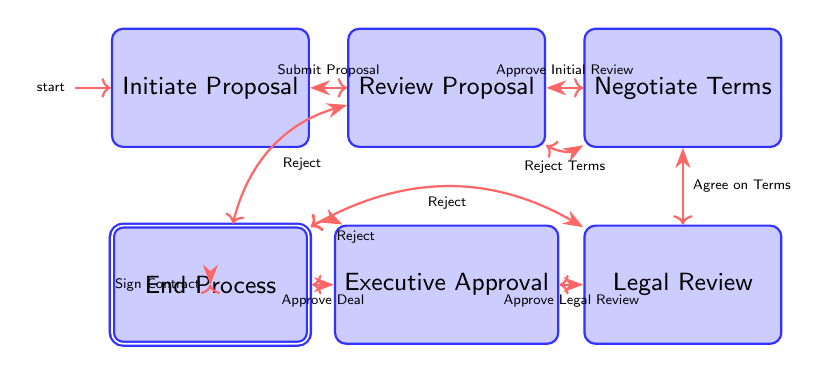What is the first node in the process? The first node in the process is labeled "Initiate Proposal," which indicates the starting point for drafting the football sponsorship proposal.
Answer: Initiate Proposal How many transitions are there from the "Review Proposal" node? The "Review Proposal" node has two transitions: one for approving the initial review and another for rejection. This totals up to two transitions.
Answer: 2 What is the final state of the process? The final state of the process is "End Process," which signifies the conclusion, either with a final deal or a rejected proposal.
Answer: End Process What happens if the proposal is rejected after the initial review? If the proposal is rejected after the initial review, the process transitions to the "End Process" node, indicating that the proposal is not pursued further.
Answer: End Process What is the outcome after "Approve Legal Review"? After "Approve Legal Review," the process transitions to the "Executive Approval" node, where the final approval is sought from top executives before proceeding.
Answer: Executive Approval If terms are rejected during negotiations, where do you go next? If the terms are rejected during negotiations, the process goes back to the "Review Proposal" node to possibly revise the proposal and renegotiate terms.
Answer: Review Proposal How many nodes are there in total in this diagram? There are a total of six nodes in the diagram: Initiate Proposal, Review Proposal, Negotiate Terms, Legal Review, Executive Approval, and Finalize Contract.
Answer: 6 What step follows "Agree on Terms"? The step that follows "Agree on Terms" is "Legal Review," where the terms of the sponsorship deal are examined for compliance with legal standards.
Answer: Legal Review What occurs after "Sign Contract"? After "Sign Contract," the process culminates in the "End Process," marking the completion of the sponsorship contract signing.
Answer: End Process 